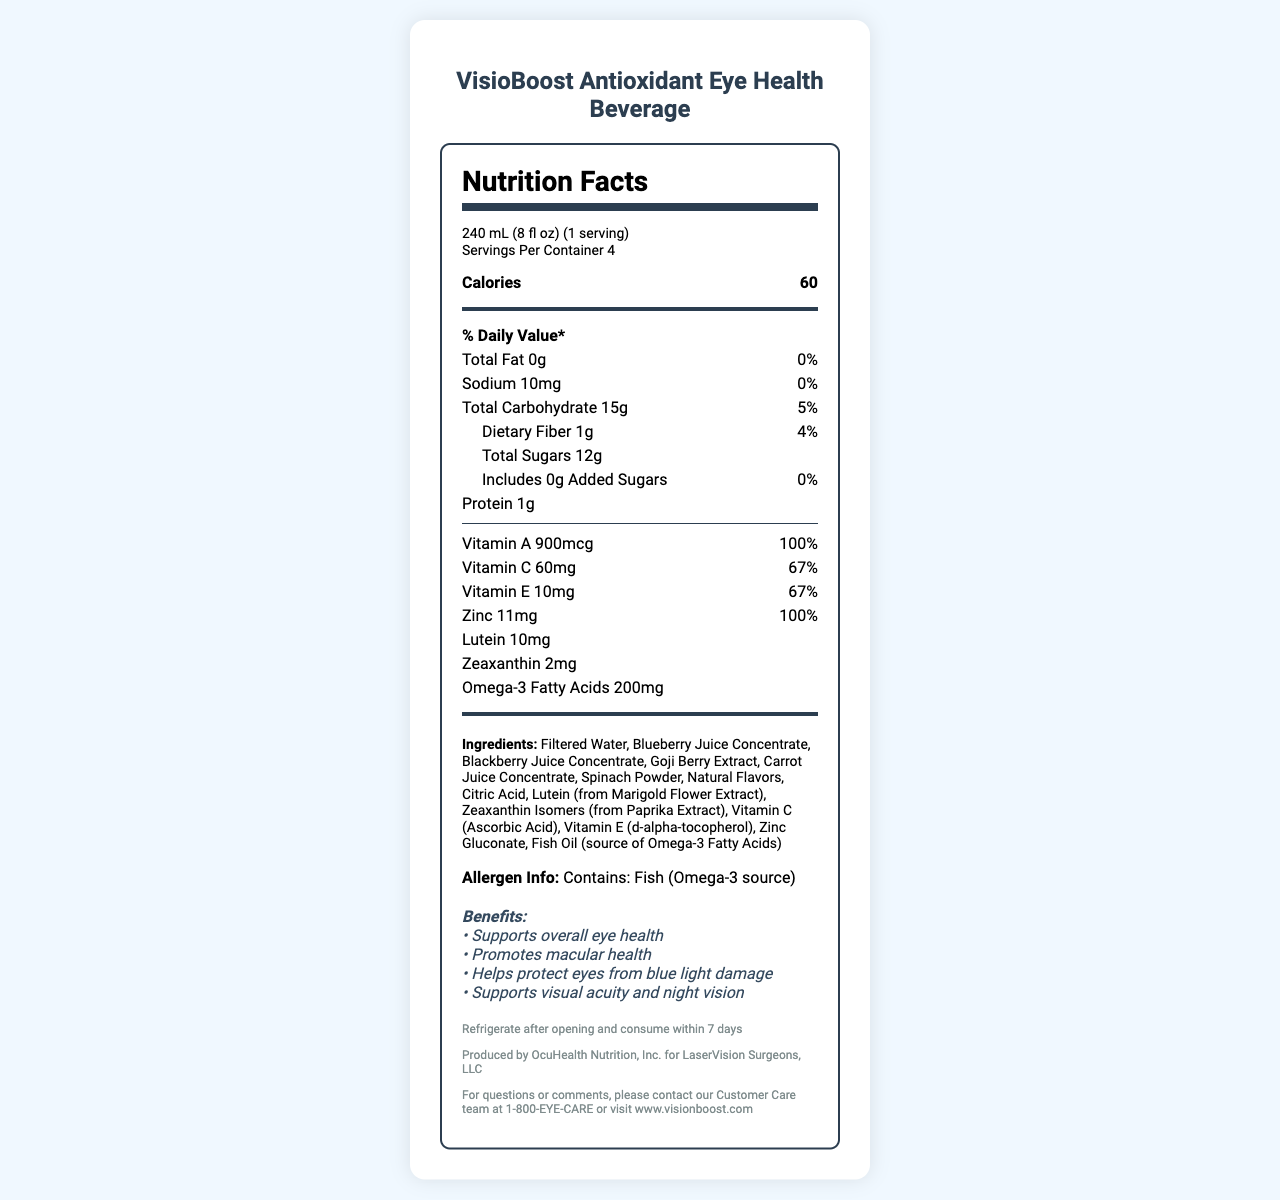what is the serving size? The serving size is stated at the beginning of the Nutrition Facts Label under "serving size."
Answer: 240 mL (8 fl oz) how many calories are there per serving? The number of calories per serving is listed directly under the serving information as "Calories 60."
Answer: 60 how many servings are there per container? The document indicates "Servings Per Container 4" in the serving information section.
Answer: 4 how much dietary fiber does one serving contain? The amount of dietary fiber per serving is listed under the "Dietary Fiber" section as "1g."
Answer: 1g what percentage of the daily value of Vitamin C does one serving provide? The percentage of the daily value of Vitamin C per serving is listed as "67%."
Answer: 67% which ingredient is the source of omega-3 fatty acids? A. Blueberry Juice Concentrate B. Fish Oil C. Citric Acid D. Zinc Gluconate The document lists "Fish Oil (source of Omega-3 Fatty Acids)" in the ingredients section.
Answer: B which vitamin has a daily value percentage of 100% per serving? A. Vitamin A B. Vitamin C C. Vitamin E D. Zinc Both Vitamin A and Zinc have a daily value percentage of 100%, as indicated in the nutrition items.
Answer: A and D does the beverage contain any added sugars? The document states "Includes 0g Added Sugars" so there are no added sugars in one serving.
Answer: No does the beverage contain any allergens? The allergen information indicates "Contains: Fish (Omega-3 source)."
Answer: Yes provide a brief summary of the document The document primarily provides detailed nutritional information about the beverage, including its health benefits, ingredients, and contact information for further inquiries.
Answer: The document is a Nutrition Facts Label for "VisioBoost Antioxidant Eye Health Beverage." It provides information about serving size, calories, and nutritional content per serving. This beverage contains antioxidants such as Vitamin A, C, E, lutein, zeaxanthin, and omega-3 fatty acids aimed at supporting overall eye health. It also includes ingredients and allergen information, storage instructions, and contact details for the manufacturer, OcuHealth Nutrition, Inc. is this beverage suitable for people with fish allergies? The allergen information clearly states that the beverage contains fish (omega-3 source), which would not be suitable for individuals with fish allergies.
Answer: No is the beverage effective in supporting visual acuity? One of the functional claims listed in the document mentions "Supports visual acuity and night vision," indicating that the beverage is intended to aid in visual acuity.
Answer: Yes from which extract is lutein derived in the beverage? The ingredients section specifies "Lutein (from Marigold Flower Extract)," indicating the source of lutein in the beverage.
Answer: Marigold Flower Extract is this beverage vegan-friendly? While the beverage contains fish oil (a source of omega-3 fatty acids), there is insufficient information provided about other potential animal-derived ingredients, making it unclear if the beverage is entirely vegan-friendly.
Answer: Cannot be determined 